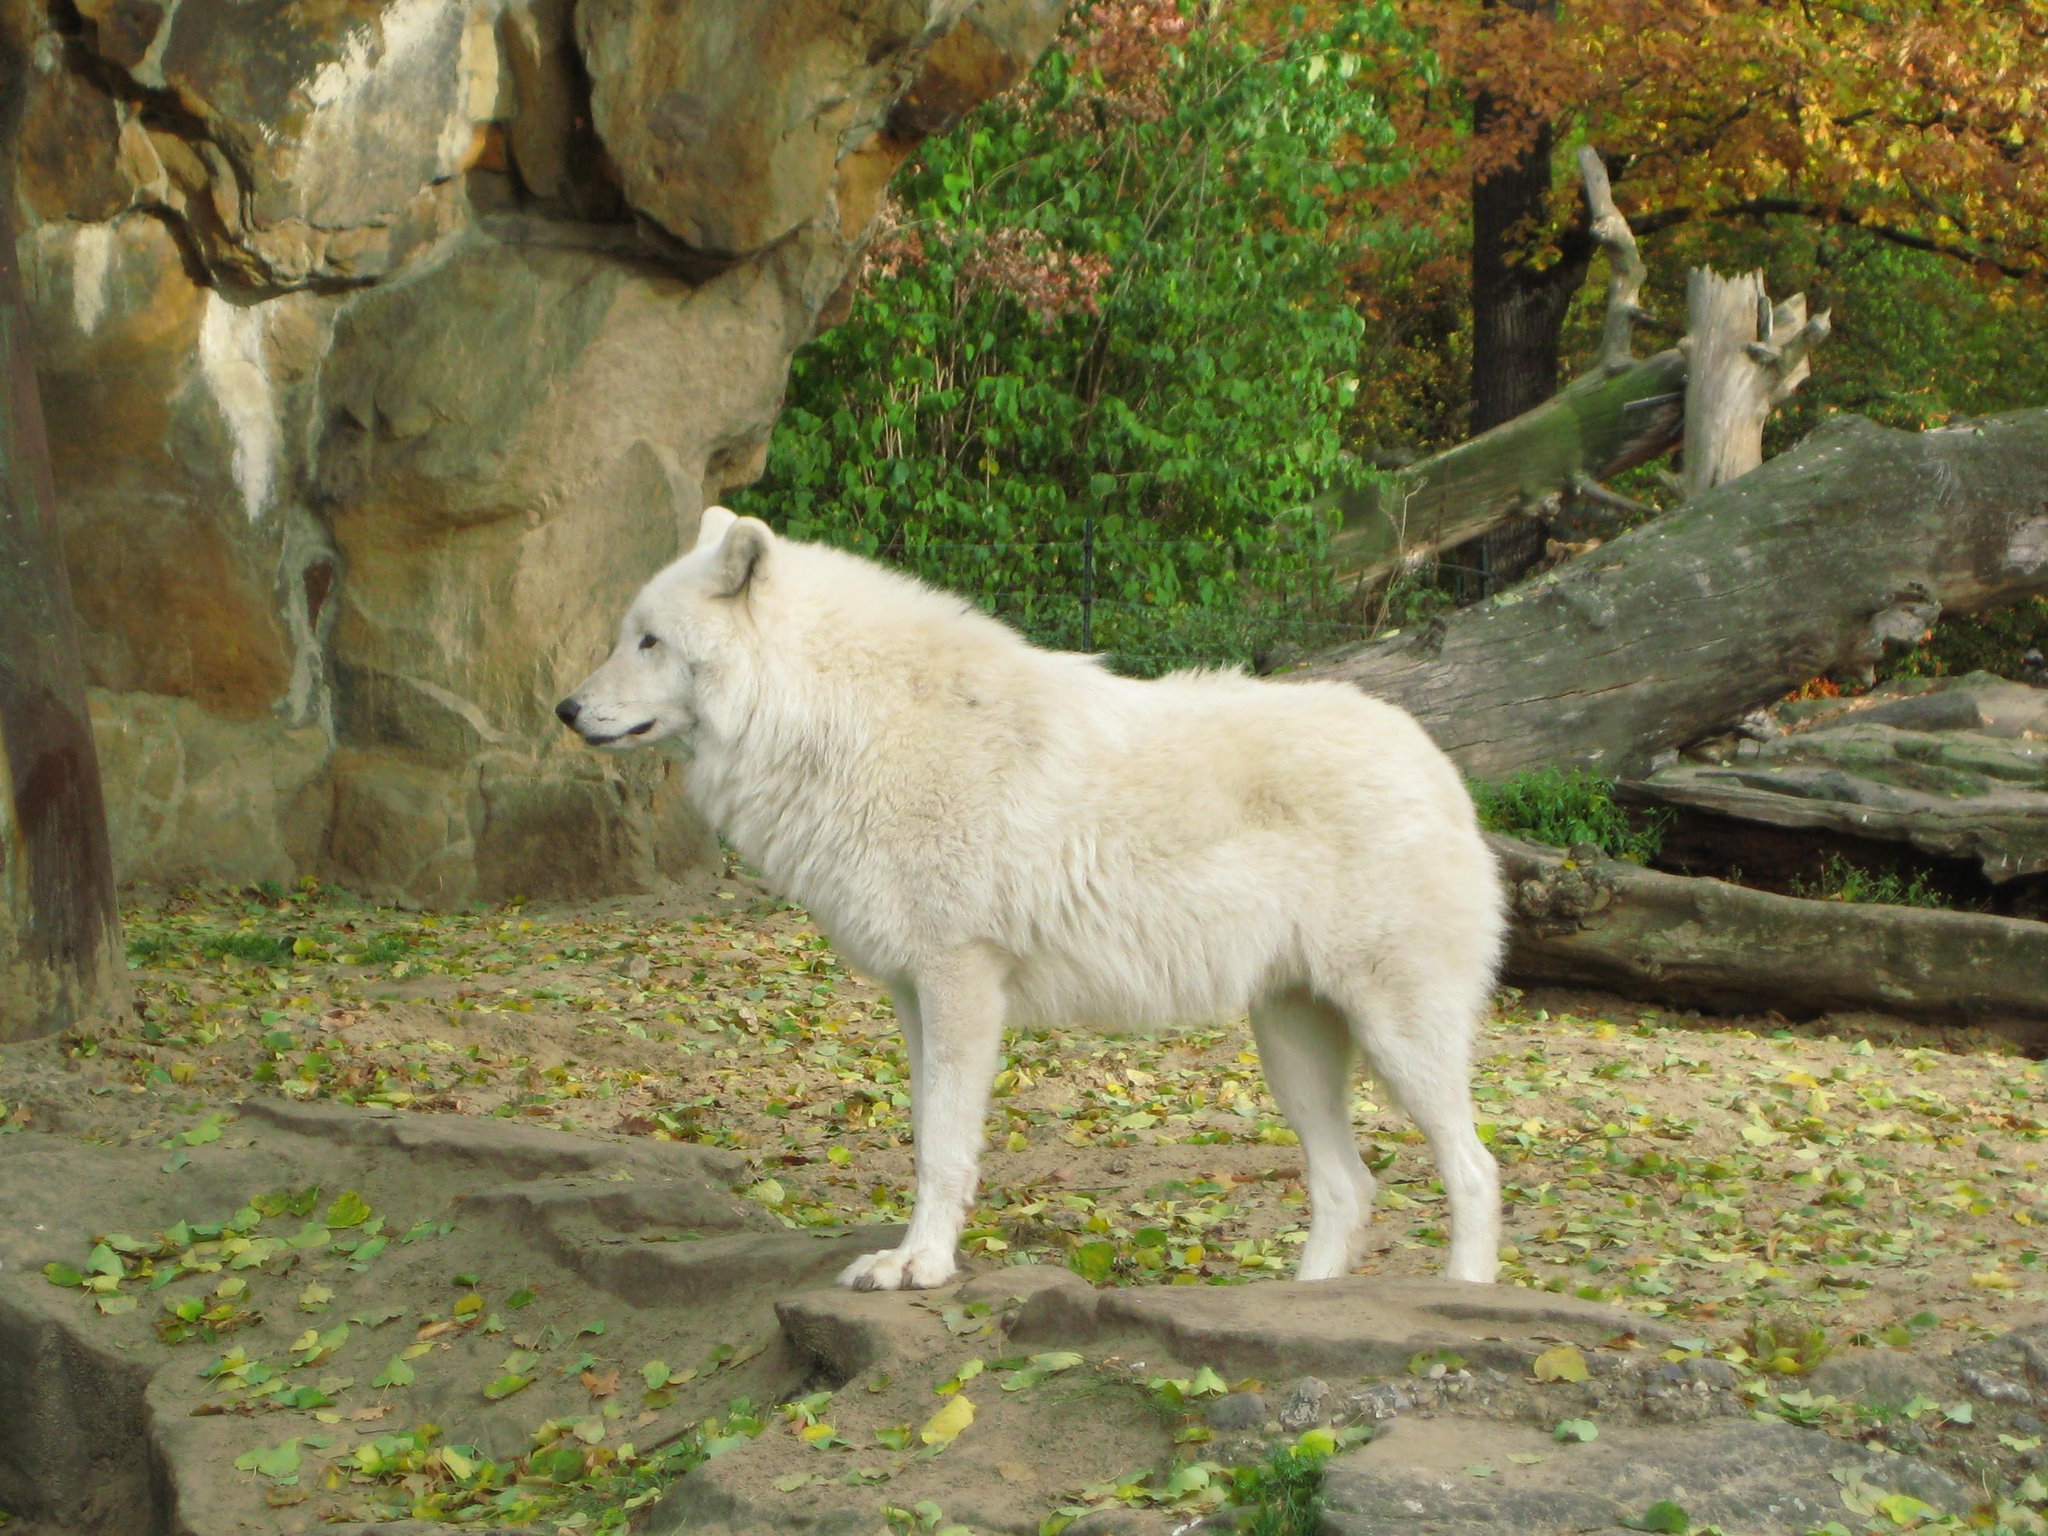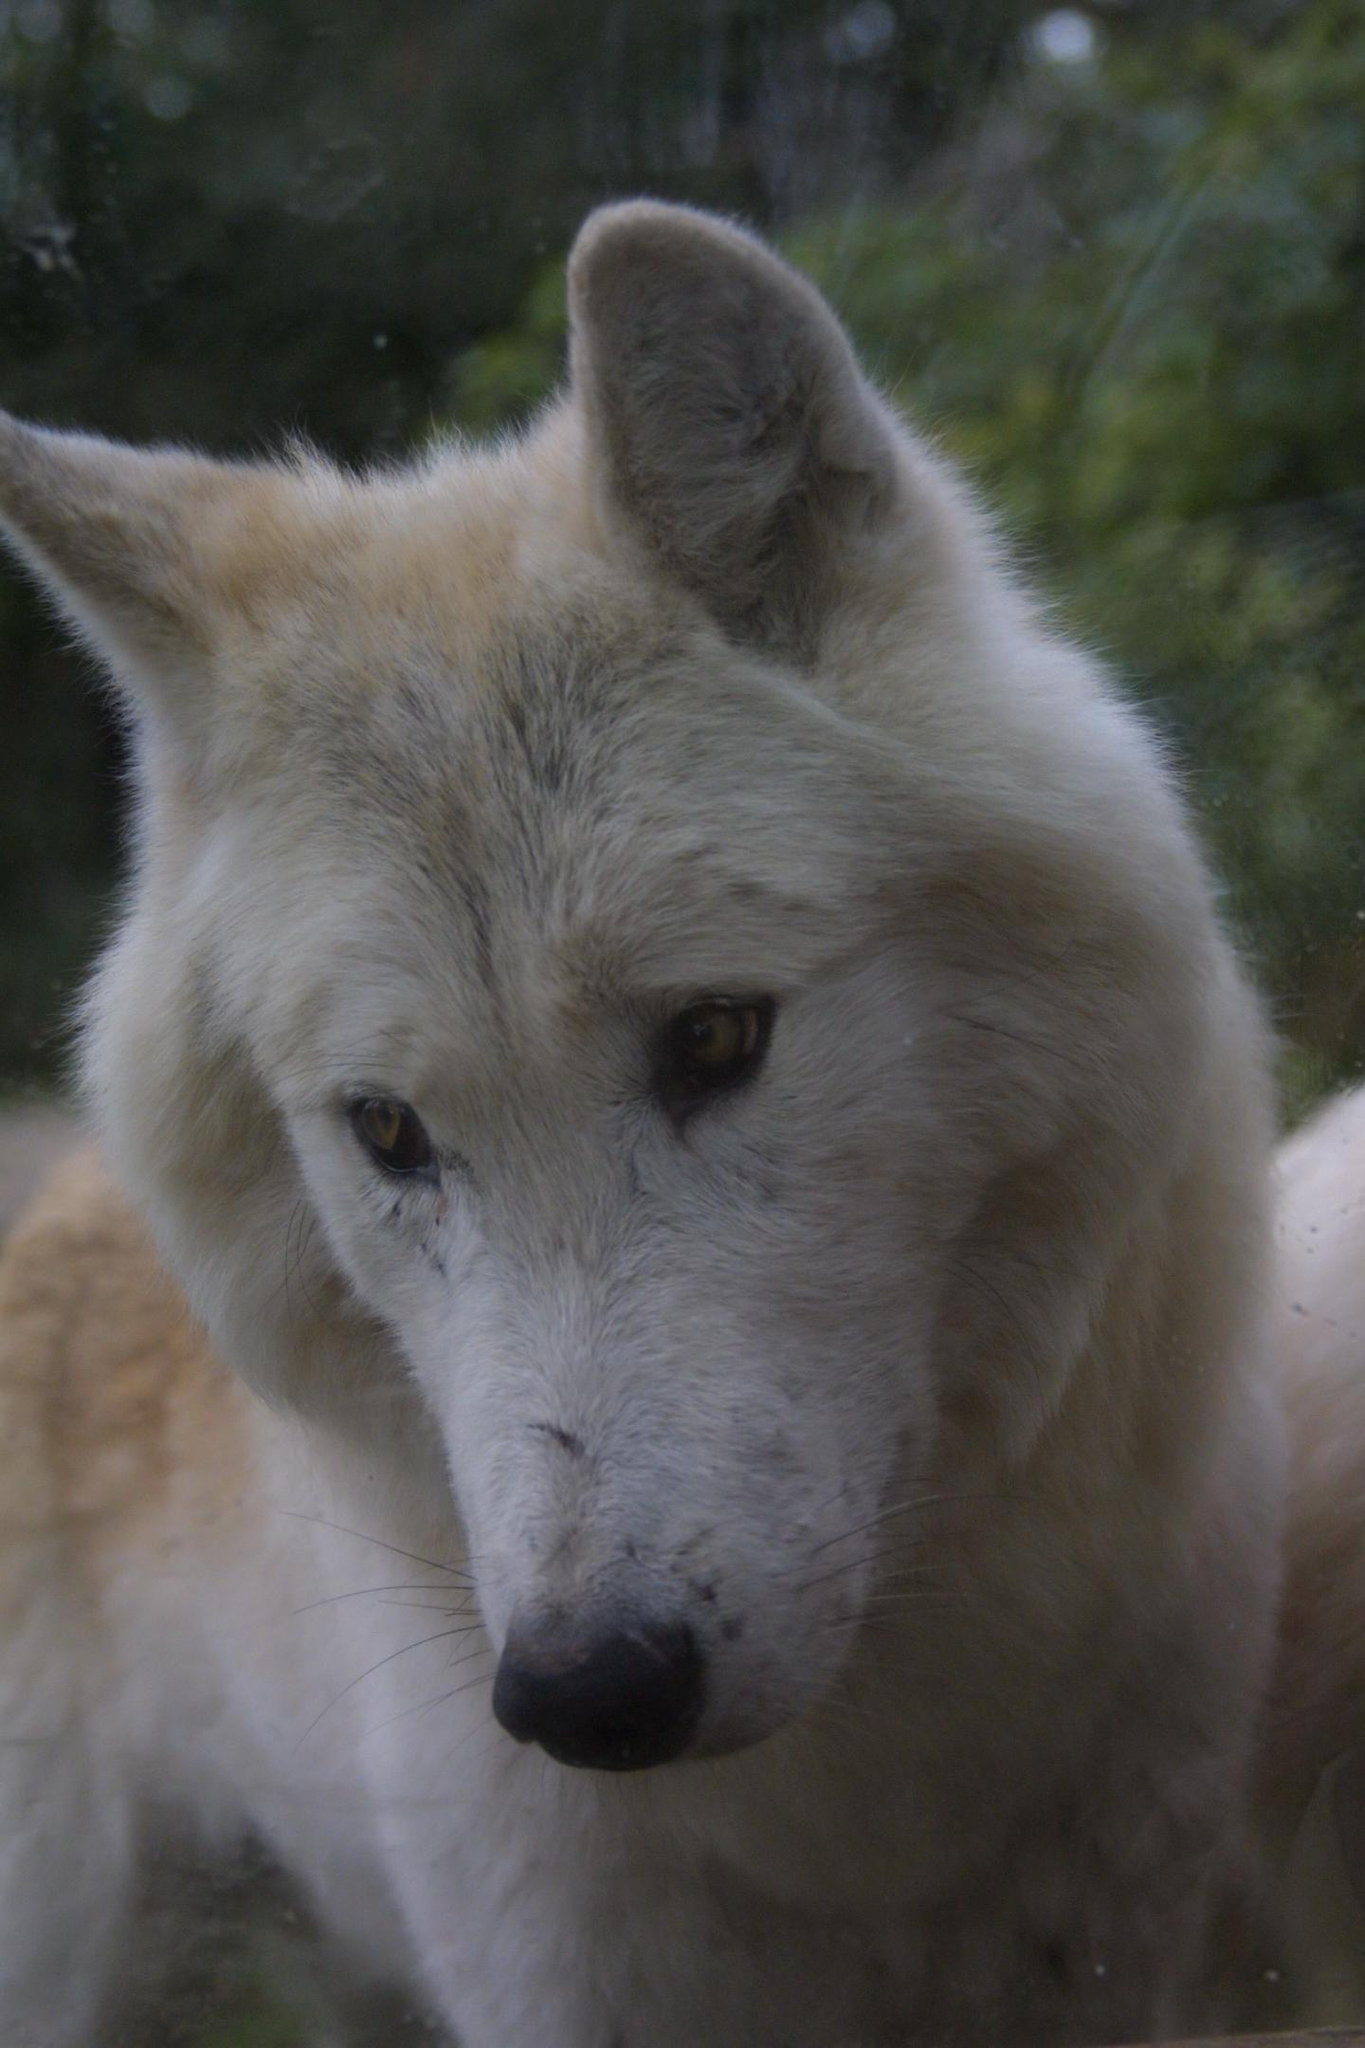The first image is the image on the left, the second image is the image on the right. For the images shown, is this caption "One of the dogs is black with a white muzzle." true? Answer yes or no. No. The first image is the image on the left, the second image is the image on the right. Examine the images to the left and right. Is the description "One of the wolves' teeth are visible." accurate? Answer yes or no. No. 